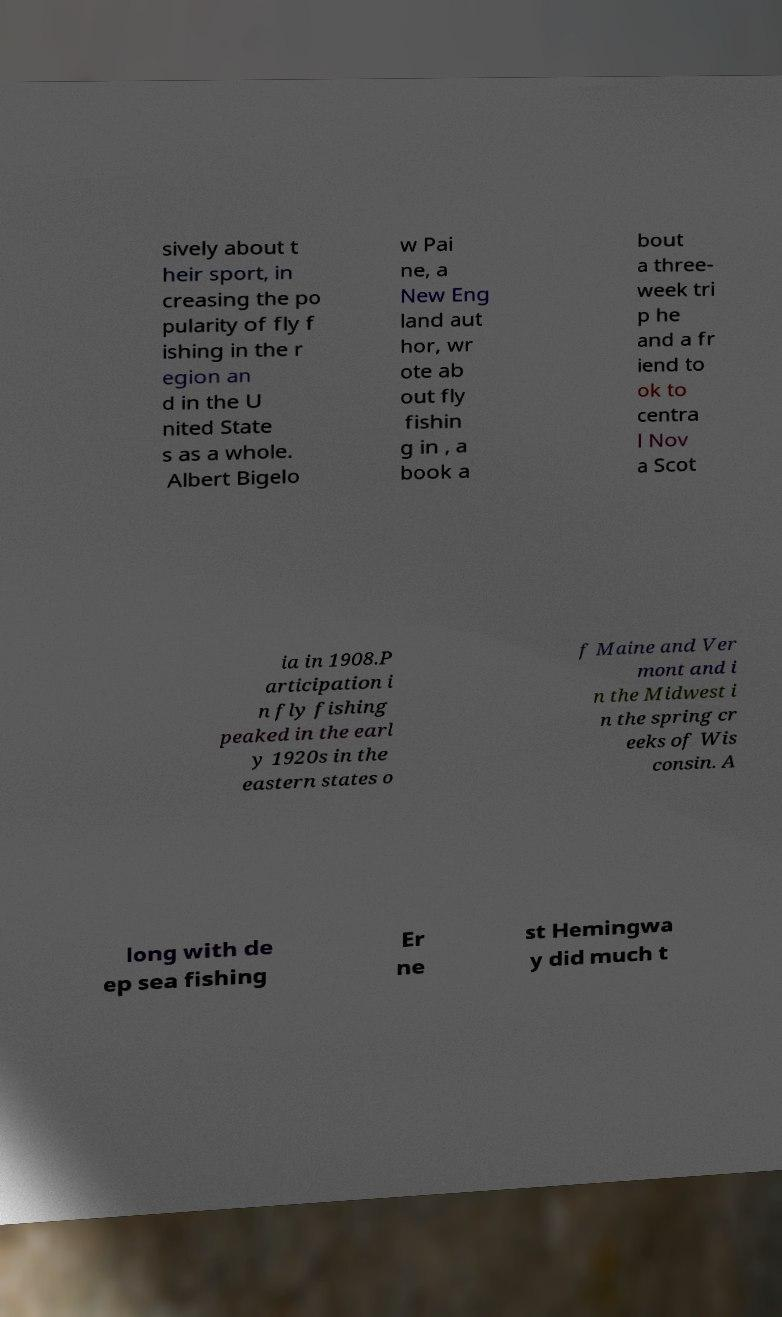What messages or text are displayed in this image? I need them in a readable, typed format. sively about t heir sport, in creasing the po pularity of fly f ishing in the r egion an d in the U nited State s as a whole. Albert Bigelo w Pai ne, a New Eng land aut hor, wr ote ab out fly fishin g in , a book a bout a three- week tri p he and a fr iend to ok to centra l Nov a Scot ia in 1908.P articipation i n fly fishing peaked in the earl y 1920s in the eastern states o f Maine and Ver mont and i n the Midwest i n the spring cr eeks of Wis consin. A long with de ep sea fishing Er ne st Hemingwa y did much t 